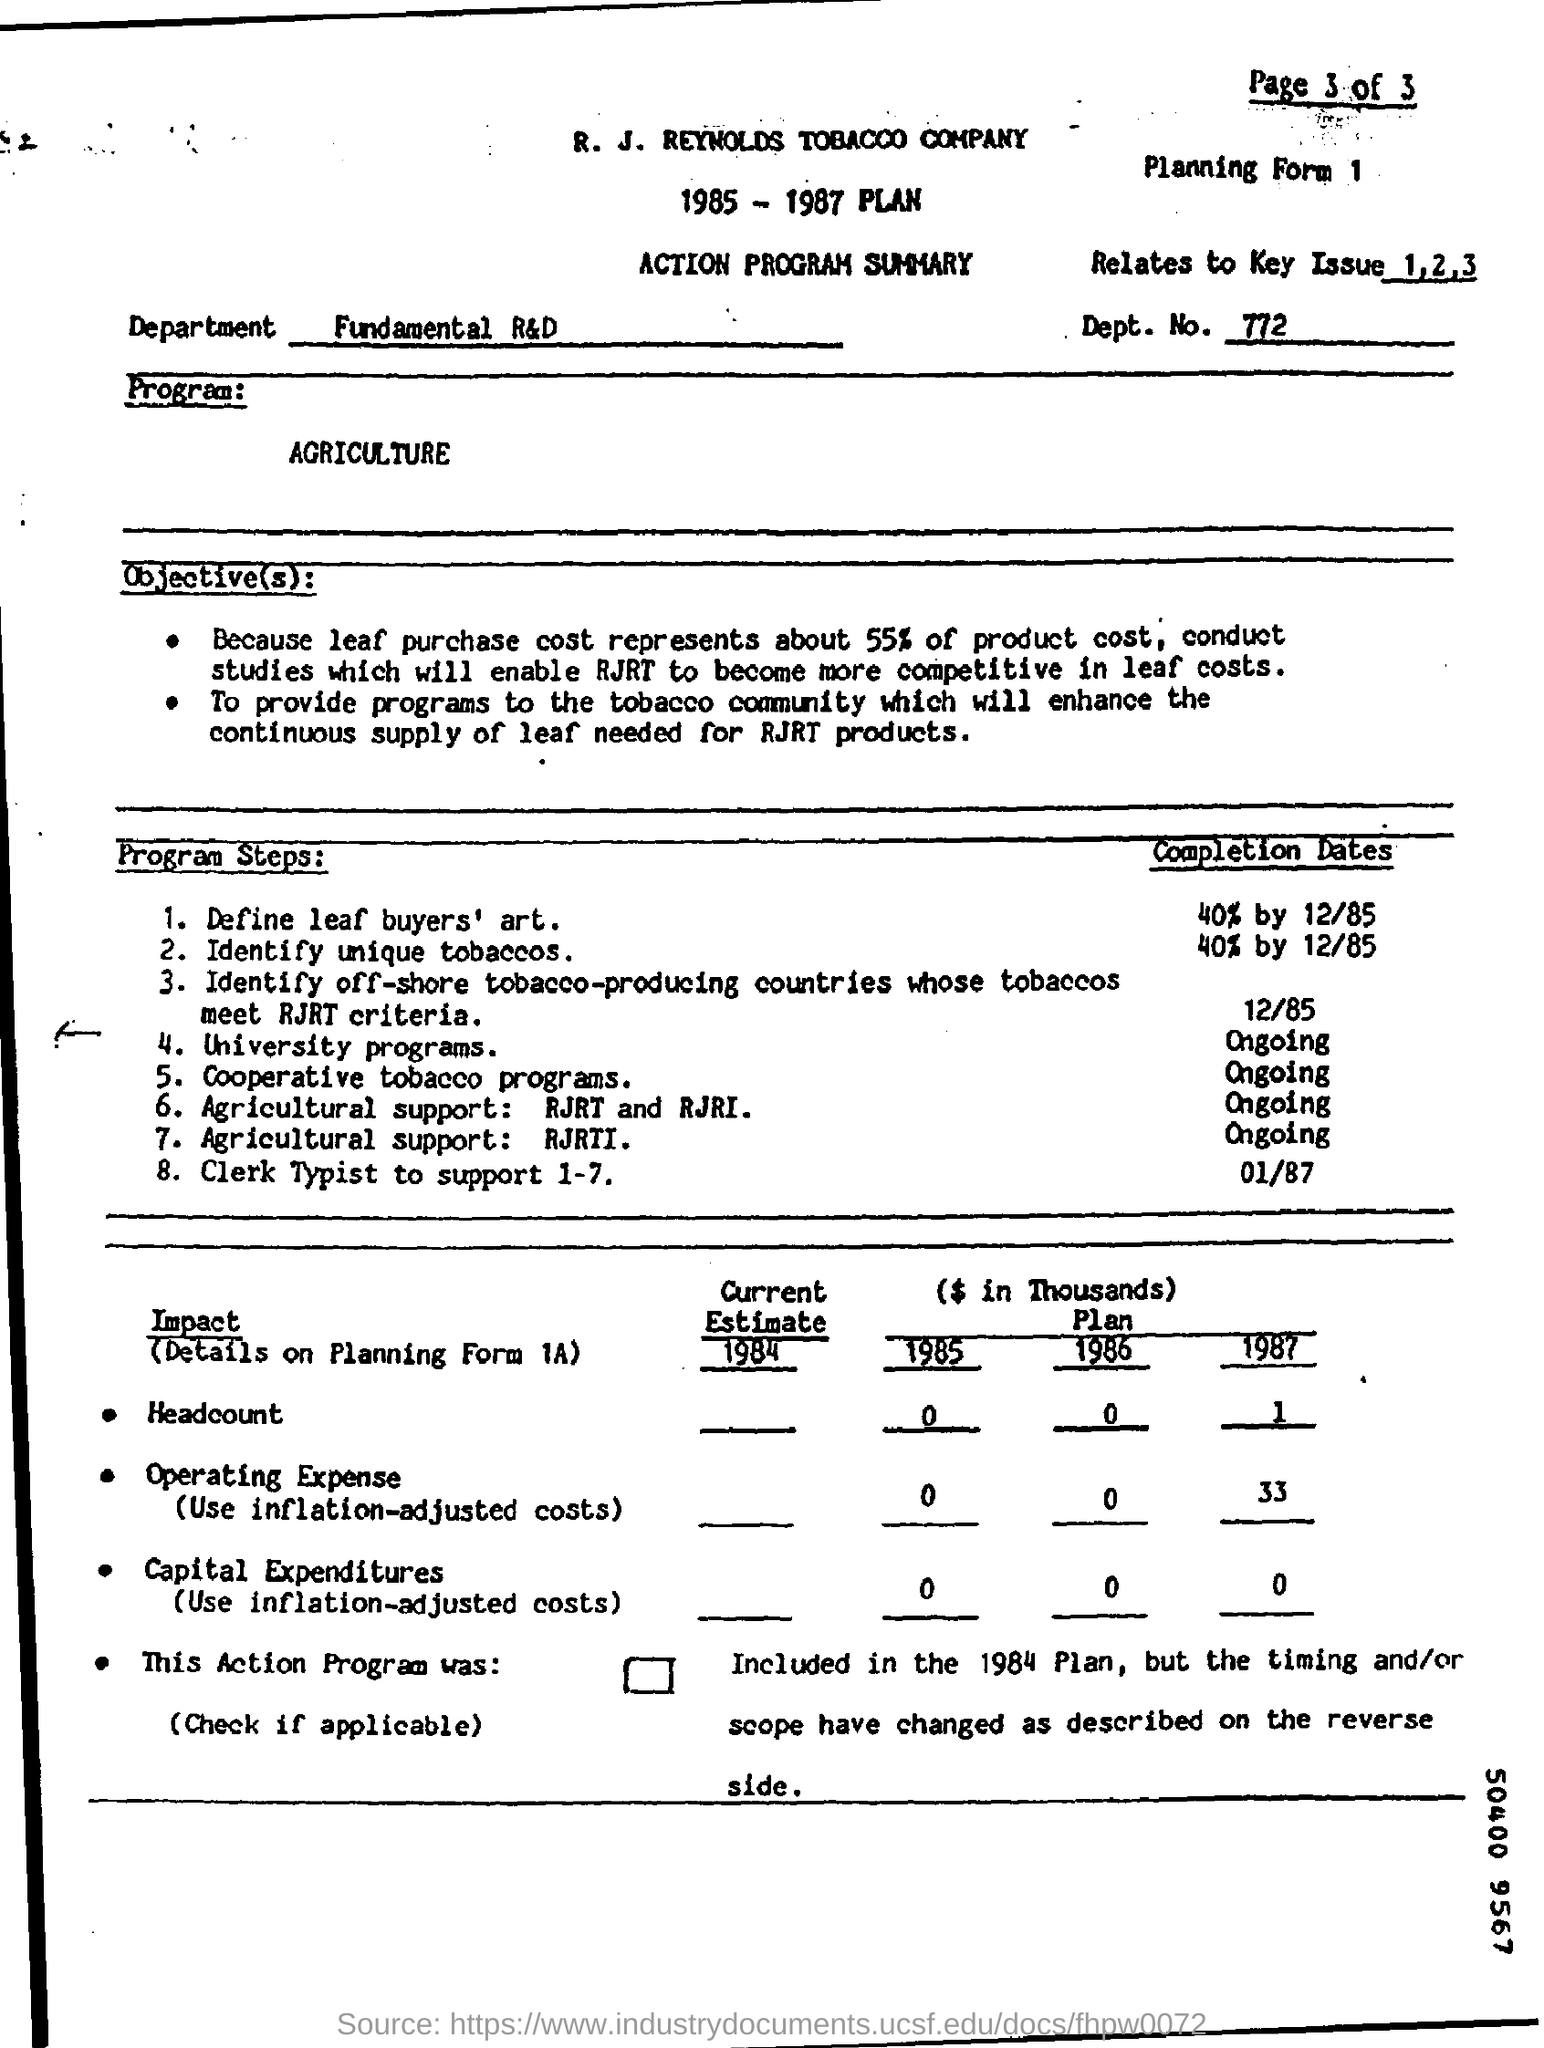What is the Company Name ?
Your response must be concise. R. J. REYNOLDS TOBACCO COMPANY. What is the Department Number ?
Provide a succinct answer. 772. What is written in the Department Field ?
Keep it short and to the point. Fundamental R&D. What is written in the Relates to Key Issue Field ?
Your answer should be compact. 1,2,3. What is written in the Program Field ?
Ensure brevity in your answer.  AGRICULTURE. 